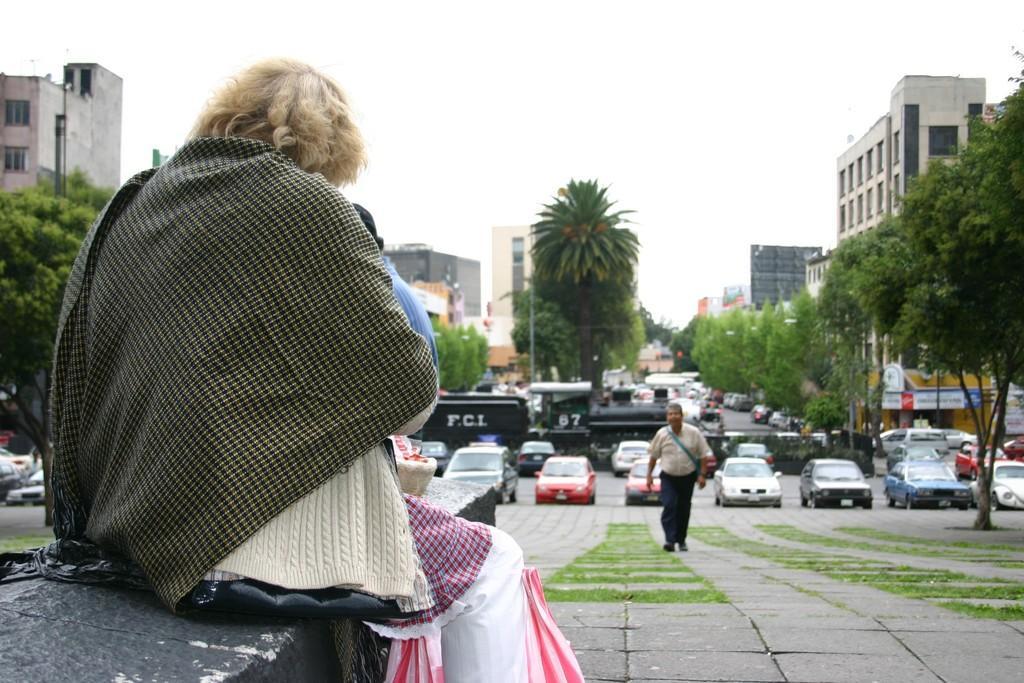Please provide a concise description of this image. In this image there is a person sitting on the wall and there is a person walking on the road, behind him there are few vehicles are moving on the road. At the center of the image there are trees. On the right and left side of the image there are buildings, in front of the buildings there are trees. In the background there is a sky. 